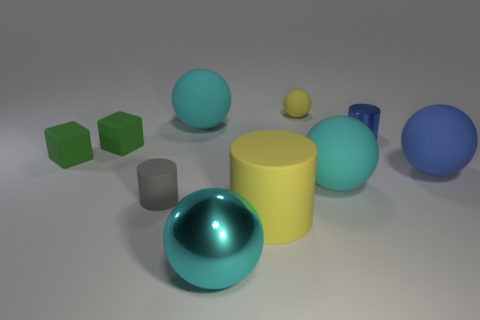Does the yellow matte object to the right of the big yellow rubber thing have the same size as the shiny object to the left of the small yellow object?
Make the answer very short. No. What material is the big ball that is both right of the cyan shiny sphere and on the left side of the small metallic thing?
Make the answer very short. Rubber. Are there fewer small metal blocks than blue matte things?
Provide a succinct answer. Yes. How big is the cyan matte object on the right side of the yellow object that is in front of the small matte cylinder?
Keep it short and to the point. Large. What shape is the cyan matte object on the left side of the big cyan thing that is in front of the rubber ball that is in front of the blue rubber ball?
Make the answer very short. Sphere. There is a big cylinder that is the same material as the gray thing; what is its color?
Give a very brief answer. Yellow. What is the color of the small object behind the small cylinder that is on the right side of the cyan sphere that is right of the big rubber cylinder?
Give a very brief answer. Yellow. What number of balls are either small red objects or gray things?
Offer a very short reply. 0. There is a large cylinder that is the same color as the small matte ball; what is its material?
Give a very brief answer. Rubber. Do the small ball and the matte cylinder that is on the right side of the small gray object have the same color?
Your response must be concise. Yes. 